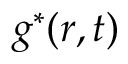<formula> <loc_0><loc_0><loc_500><loc_500>g ^ { \ast } ( r , t )</formula> 